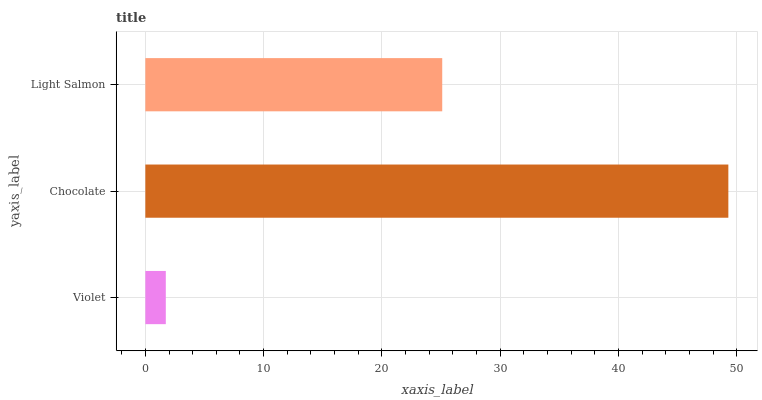Is Violet the minimum?
Answer yes or no. Yes. Is Chocolate the maximum?
Answer yes or no. Yes. Is Light Salmon the minimum?
Answer yes or no. No. Is Light Salmon the maximum?
Answer yes or no. No. Is Chocolate greater than Light Salmon?
Answer yes or no. Yes. Is Light Salmon less than Chocolate?
Answer yes or no. Yes. Is Light Salmon greater than Chocolate?
Answer yes or no. No. Is Chocolate less than Light Salmon?
Answer yes or no. No. Is Light Salmon the high median?
Answer yes or no. Yes. Is Light Salmon the low median?
Answer yes or no. Yes. Is Violet the high median?
Answer yes or no. No. Is Violet the low median?
Answer yes or no. No. 